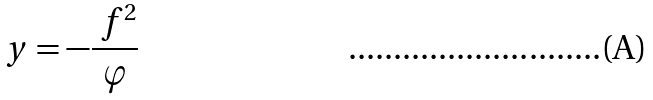<formula> <loc_0><loc_0><loc_500><loc_500>\ y = - \frac { \ f ^ { 2 } } { \varphi }</formula> 